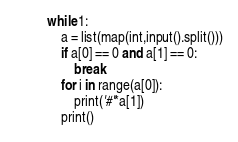<code> <loc_0><loc_0><loc_500><loc_500><_Python_>while 1:
    a = list(map(int,input().split()))
    if a[0] == 0 and a[1] == 0:
        break
    for i in range(a[0]):
        print('#'*a[1])
    print()
</code> 